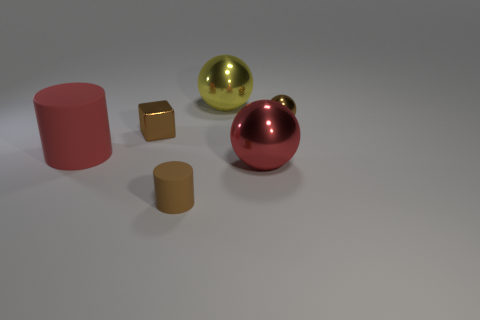Subtract all large balls. How many balls are left? 1 Add 2 large red matte cylinders. How many objects exist? 8 Subtract all cylinders. How many objects are left? 4 Subtract all brown cylinders. How many cylinders are left? 1 Subtract 0 blue cylinders. How many objects are left? 6 Subtract all gray cylinders. Subtract all gray blocks. How many cylinders are left? 2 Subtract all tiny brown shiny things. Subtract all balls. How many objects are left? 1 Add 5 blocks. How many blocks are left? 6 Add 6 large shiny objects. How many large shiny objects exist? 8 